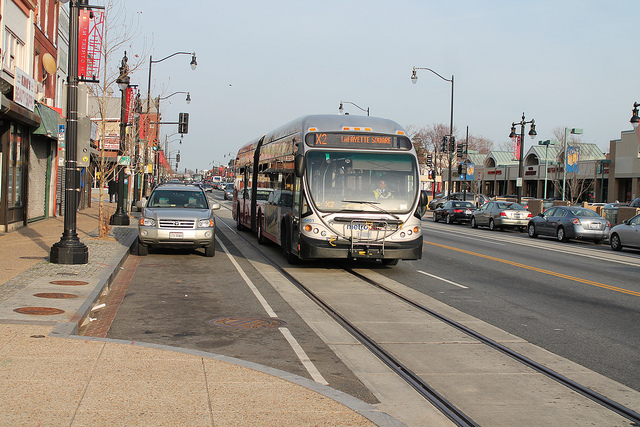<image>Where is the bus going? It is ambiguous where the bus is going. Possible destinations include Everett, Gemist Square, Grant Street, or Downtown. Where is the bus going? I am not sure where the bus is going. It can be going to Everett, Gemist Square, Grant Street, or downtown. 